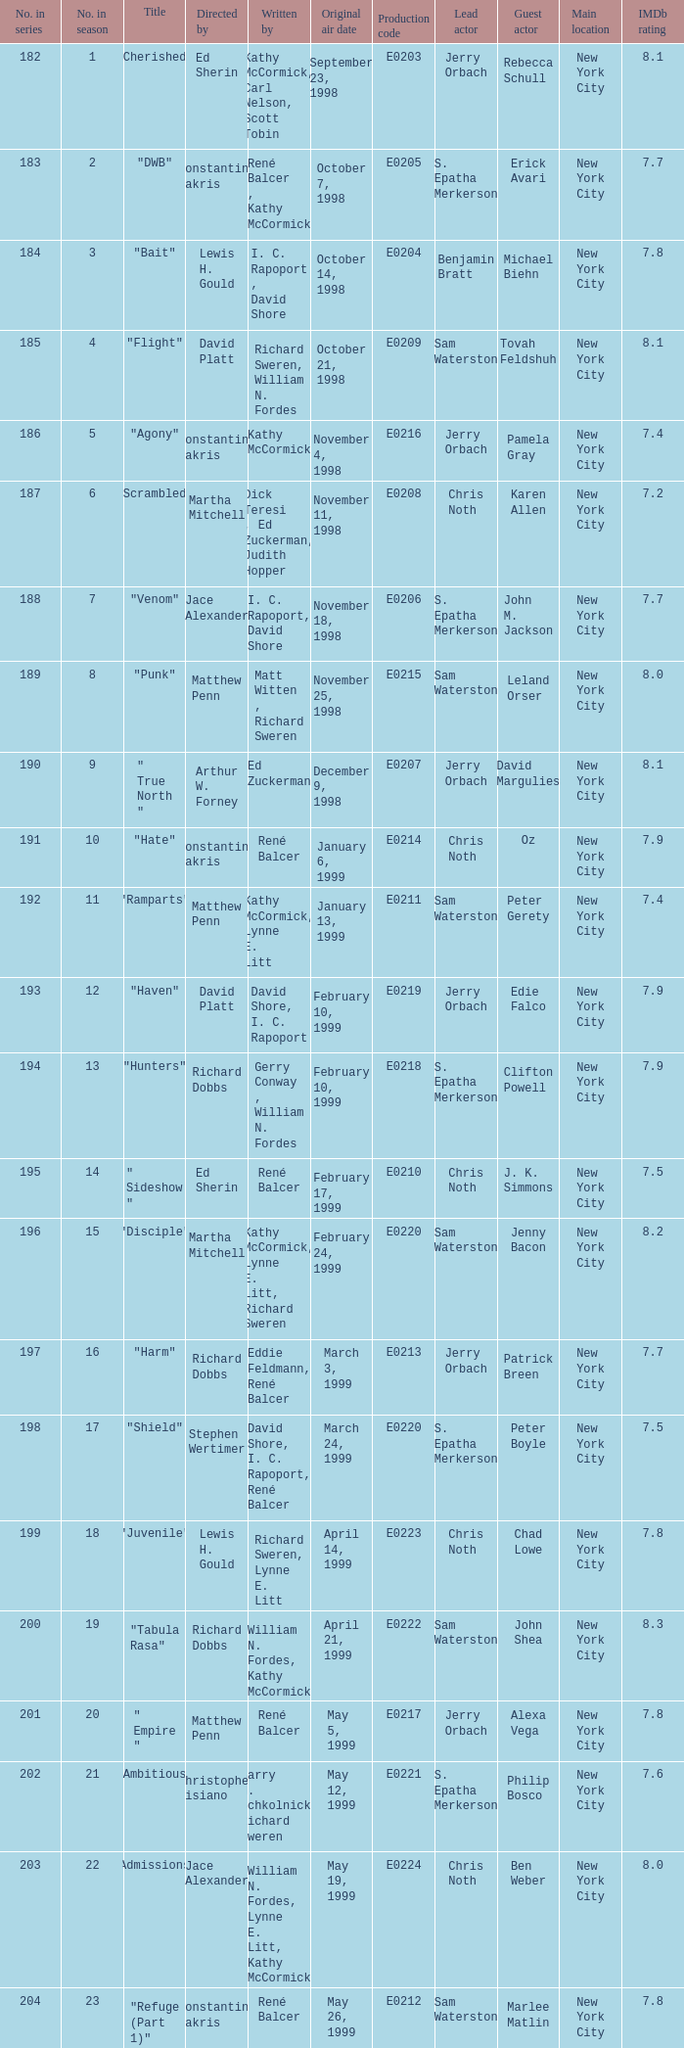Would you mind parsing the complete table? {'header': ['No. in series', 'No. in season', 'Title', 'Directed by', 'Written by', 'Original air date', 'Production code', 'Lead actor', 'Guest actor', 'Main location', 'IMDb rating'], 'rows': [['182', '1', '"Cherished"', 'Ed Sherin', 'Kathy McCormick, Carl Nelson, Scott Tobin', 'September 23, 1998', 'E0203', 'Jerry Orbach', 'Rebecca Schull', 'New York City', '8.1'], ['183', '2', '"DWB"', 'Constantine Makris', 'René Balcer , Kathy McCormick', 'October 7, 1998', 'E0205', 'S. Epatha Merkerson', 'Erick Avari', 'New York City', '7.7'], ['184', '3', '"Bait"', 'Lewis H. Gould', 'I. C. Rapoport , David Shore', 'October 14, 1998', 'E0204', 'Benjamin Bratt', 'Michael Biehn', 'New York City', '7.8'], ['185', '4', '"Flight"', 'David Platt', 'Richard Sweren, William N. Fordes', 'October 21, 1998', 'E0209', 'Sam Waterston', 'Tovah Feldshuh', 'New York City', '8.1'], ['186', '5', '"Agony"', 'Constantine Makris', 'Kathy McCormick', 'November 4, 1998', 'E0216', 'Jerry Orbach', 'Pamela Gray', 'New York City', '7.4'], ['187', '6', '"Scrambled"', 'Martha Mitchell', 'Dick Teresi , Ed Zuckerman, Judith Hopper', 'November 11, 1998', 'E0208', 'Chris Noth', 'Karen Allen', 'New York City', '7.2'], ['188', '7', '"Venom"', 'Jace Alexander', 'I. C. Rapoport, David Shore', 'November 18, 1998', 'E0206', 'S. Epatha Merkerson', 'John M. Jackson', 'New York City', '7.7'], ['189', '8', '"Punk"', 'Matthew Penn', 'Matt Witten , Richard Sweren', 'November 25, 1998', 'E0215', 'Sam Waterston', 'Leland Orser', 'New York City', '8.0'], ['190', '9', '" True North "', 'Arthur W. Forney', 'Ed Zuckerman', 'December 9, 1998', 'E0207', 'Jerry Orbach', 'David Margulies', 'New York City', '8.1'], ['191', '10', '"Hate"', 'Constantine Makris', 'René Balcer', 'January 6, 1999', 'E0214', 'Chris Noth', 'Oz', 'New York City', '7.9'], ['192', '11', '"Ramparts"', 'Matthew Penn', 'Kathy McCormick, Lynne E. Litt', 'January 13, 1999', 'E0211', 'Sam Waterston', 'Peter Gerety', 'New York City', '7.4'], ['193', '12', '"Haven"', 'David Platt', 'David Shore, I. C. Rapoport', 'February 10, 1999', 'E0219', 'Jerry Orbach', 'Edie Falco', 'New York City', '7.9'], ['194', '13', '"Hunters"', 'Richard Dobbs', 'Gerry Conway , William N. Fordes', 'February 10, 1999', 'E0218', 'S. Epatha Merkerson', 'Clifton Powell', 'New York City', '7.9'], ['195', '14', '" Sideshow "', 'Ed Sherin', 'René Balcer', 'February 17, 1999', 'E0210', 'Chris Noth', 'J. K. Simmons', 'New York City', '7.5'], ['196', '15', '"Disciple"', 'Martha Mitchell', 'Kathy McCormick, Lynne E. Litt, Richard Sweren', 'February 24, 1999', 'E0220', 'Sam Waterston', 'Jenny Bacon', 'New York City', '8.2'], ['197', '16', '"Harm"', 'Richard Dobbs', 'Eddie Feldmann, René Balcer', 'March 3, 1999', 'E0213', 'Jerry Orbach', 'Patrick Breen', 'New York City', '7.7'], ['198', '17', '"Shield"', 'Stephen Wertimer', 'David Shore, I. C. Rapoport, René Balcer', 'March 24, 1999', 'E0220', 'S. Epatha Merkerson', 'Peter Boyle', 'New York City', '7.5'], ['199', '18', '"Juvenile"', 'Lewis H. Gould', 'Richard Sweren, Lynne E. Litt', 'April 14, 1999', 'E0223', 'Chris Noth', 'Chad Lowe', 'New York City', '7.8'], ['200', '19', '"Tabula Rasa"', 'Richard Dobbs', 'William N. Fordes, Kathy McCormick', 'April 21, 1999', 'E0222', 'Sam Waterston', 'John Shea', 'New York City', '8.3'], ['201', '20', '" Empire "', 'Matthew Penn', 'René Balcer', 'May 5, 1999', 'E0217', 'Jerry Orbach', 'Alexa Vega', 'New York City', '7.8'], ['202', '21', '"Ambitious"', 'Christopher Misiano', 'Barry M. Schkolnick, Richard Sweren', 'May 12, 1999', 'E0221', 'S. Epatha Merkerson', 'Philip Bosco', 'New York City', '7.6'], ['203', '22', '"Admissions"', 'Jace Alexander', 'William N. Fordes, Lynne E. Litt, Kathy McCormick', 'May 19, 1999', 'E0224', 'Chris Noth', 'Ben Weber', 'New York City', '8.0'], ['204', '23', '"Refuge (Part 1)"', 'Constantine Makris', 'René Balcer', 'May 26, 1999', 'E0212', 'Sam Waterston', 'Marlee Matlin', 'New York City', '7.8']]} What is the season number of the episode written by Matt Witten , Richard Sweren? 8.0. 